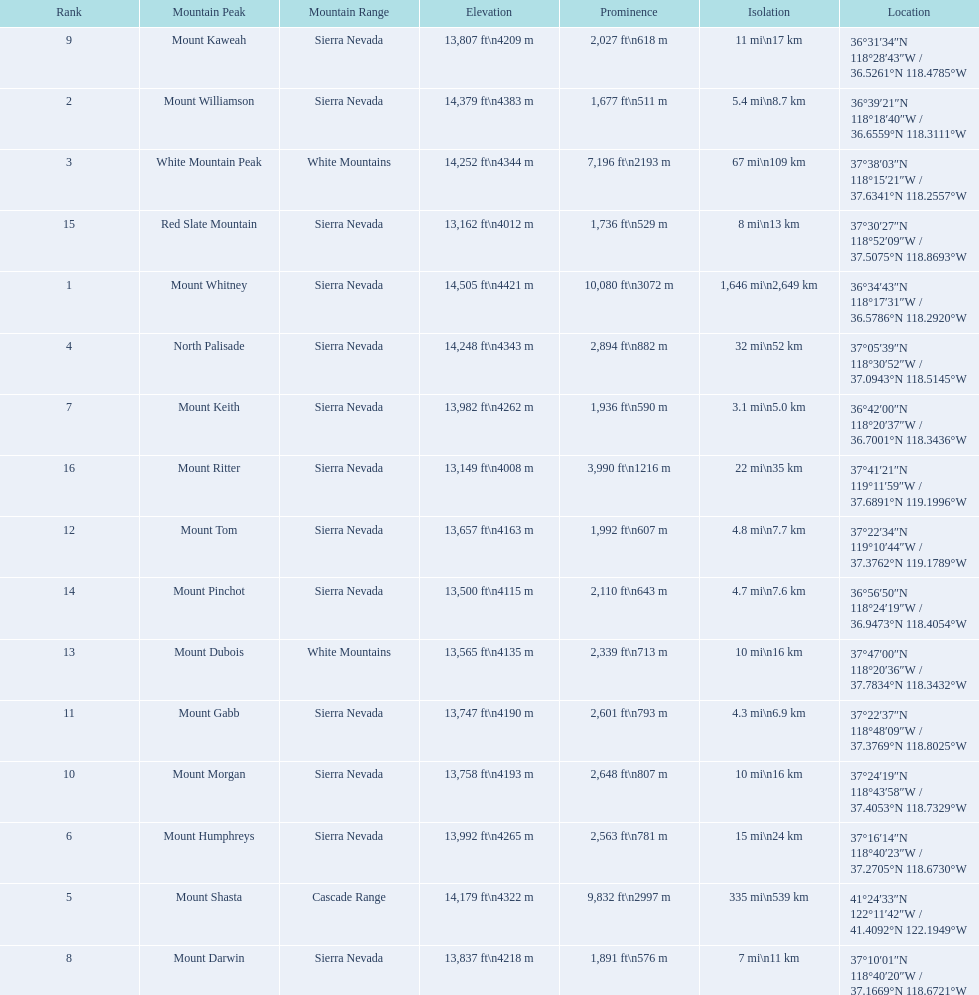What are the mountain peaks? Mount Whitney, Mount Williamson, White Mountain Peak, North Palisade, Mount Shasta, Mount Humphreys, Mount Keith, Mount Darwin, Mount Kaweah, Mount Morgan, Mount Gabb, Mount Tom, Mount Dubois, Mount Pinchot, Red Slate Mountain, Mount Ritter. Of these, which one has a prominence more than 10,000 ft? Mount Whitney. 